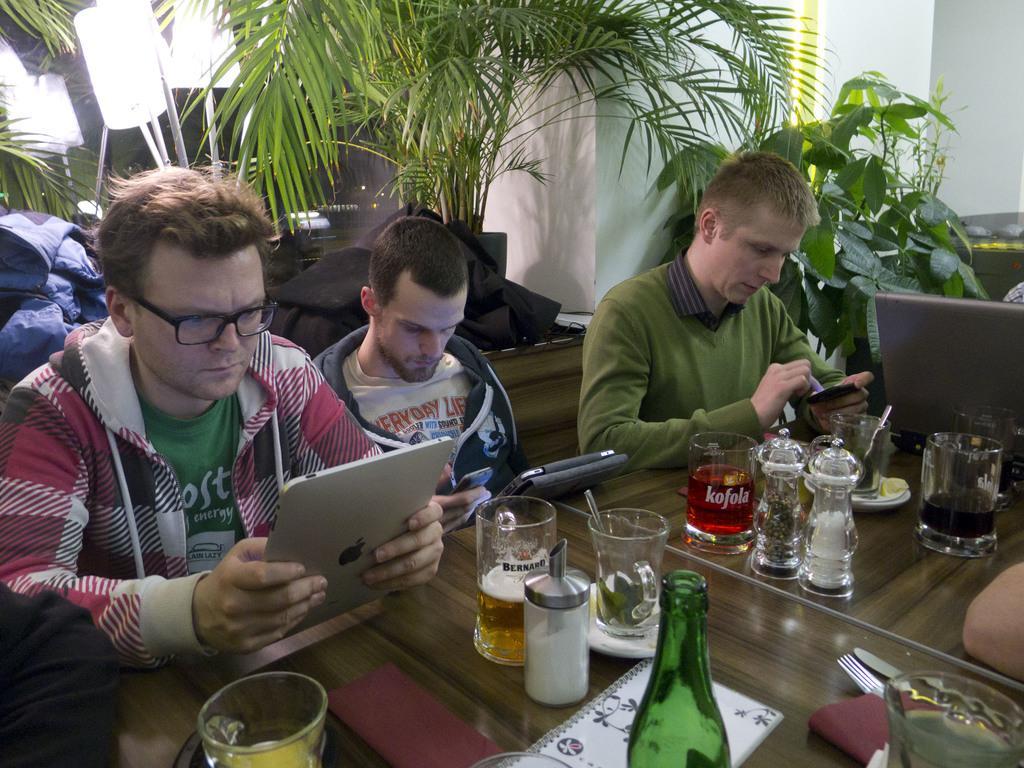In one or two sentences, can you explain what this image depicts? It seems to be the image is inside the restaurant. There are three people in the image who are sitting on chairs and holding their tablets and mobiles in front of a table. On table we can see glasses,menu card,fork,knife,spoon,plate,juice on right side there is a plant with green leaves. In middle there are some trees,lights,jackets and a wall which is in white color. 